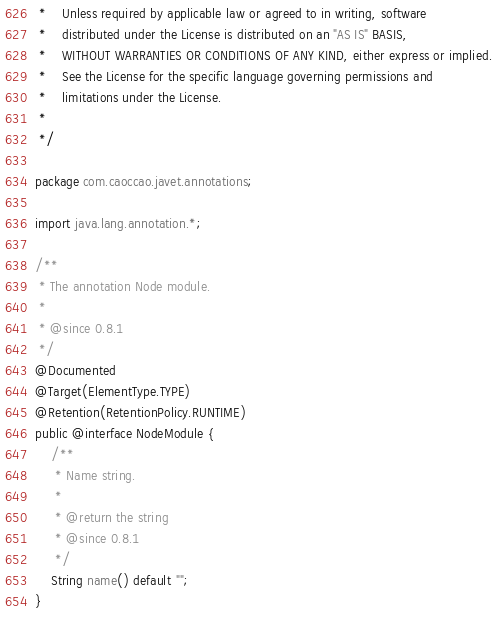Convert code to text. <code><loc_0><loc_0><loc_500><loc_500><_Java_> *    Unless required by applicable law or agreed to in writing, software
 *    distributed under the License is distributed on an "AS IS" BASIS,
 *    WITHOUT WARRANTIES OR CONDITIONS OF ANY KIND, either express or implied.
 *    See the License for the specific language governing permissions and
 *    limitations under the License.
 *
 */

package com.caoccao.javet.annotations;

import java.lang.annotation.*;

/**
 * The annotation Node module.
 *
 * @since 0.8.1
 */
@Documented
@Target(ElementType.TYPE)
@Retention(RetentionPolicy.RUNTIME)
public @interface NodeModule {
    /**
     * Name string.
     *
     * @return the string
     * @since 0.8.1
     */
    String name() default "";
}
</code> 